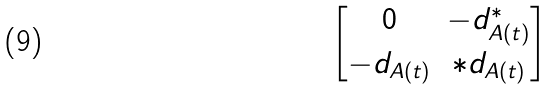<formula> <loc_0><loc_0><loc_500><loc_500>\begin{bmatrix} 0 & - d ^ { * } _ { A ( t ) } \\ - d _ { A ( t ) } & * d _ { A ( t ) } \end{bmatrix}</formula> 